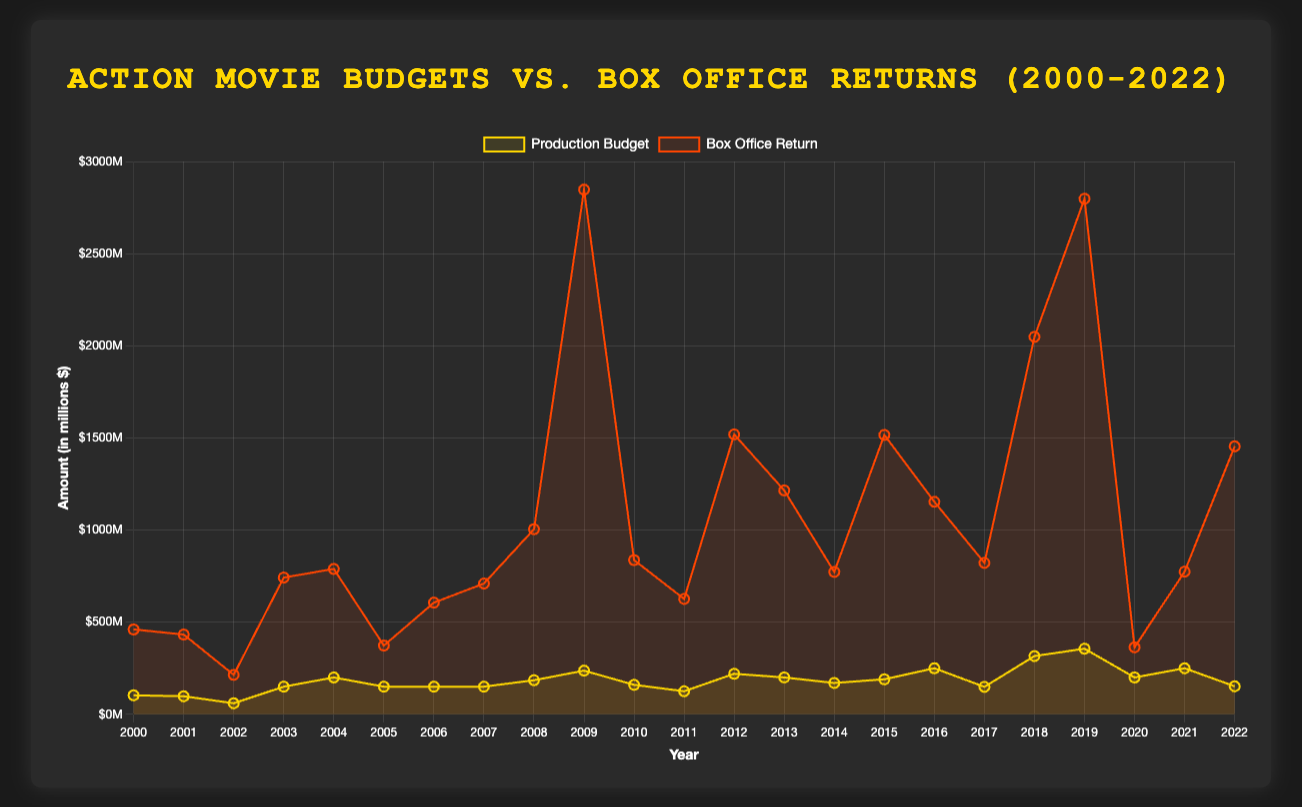Which movie had the highest box office return? To determine the movie with the highest box office return, look for the peak on the "Box Office Return" line. The figure shows that the highest point is in 2009 for "Avatar".
Answer: Avatar Which year saw the largest increase in production budget compared to the previous year? To find the largest increase in production budget, compare the vertical distances between consecutive points on the "Production Budget" line. The significant increase is from 2007 (150M for Transformers) to 2008 (185M for The Dark Knight), an increase of 35M.
Answer: 2008 In which year did the box office return surpass $1 billion for the first time? To identify when the box office return first surpassed $1 billion, look for the first point above the $1 billion mark on the "Box Office Return" line. This occurs in 2008 with "The Dark Knight".
Answer: 2008 What is the average box office return for the movies released in even years between 2000 and 2022? Calculate the average box office return for all movies released in even years (2000, 2002, 2004, ..., 2022). The returns are: 460.58M (2000), 214.03M (2002), 789M (2004), 606.1M (2006), 1004.56M (2008), 836.85M (2010), 1214.81M (2012), 772.78M (2014), 1516.05M (2016), 2048.36M (2018), 363.66M (2020), 1454.35M (2022). The sum is 11271.67M, and there are 12 movies, hence the average is 939.31M.
Answer: 939.31M Which movie had a production budget of $250 million and what was its box office return? Look for the data point on the "Production Budget" line where the value is $250 million. This budget corresponds to two movies: "Captain America: Civil War" in 2016 and "No Time to Die" in 2021. Their box office returns are 1153.30M and 774.15M respectively.
Answer: Captain America: Civil War, 1153.30M and No Time to Die, 774.15M Which year saw the largest disparity between production budget and box office return? To determine the year with the largest disparity between production budget and box office return, calculate the difference between the two values for each year. The largest disparity appears to be in 2009 for "Avatar" with a budget of 237M and a return of 2847.25M, resulting in a difference of 2610.25M.
Answer: 2009 How did the box office return for "Gladiator" compare to the "Iron Man 3"? Compare the box office returns for "Gladiator" in 2000 and "Iron Man 3" in 2013. "Gladiator" had a return of 460.58M while "Iron Man 3" had a return of 1214.81M. "Iron Man 3" significantly outperformed "Gladiator".
Answer: Iron Man 3 outperformed Gladiator Which movie in the 2010s had the highest production budget and what was it? Locate the highest point on the "Production Budget" line within the 2010-2019 range. This peak occurs in 2019 with "Avengers: Endgame", which had a budget of $356 million.
Answer: Avengers: Endgame, 356M What is the total box office return for the "Avengers" series listed in the data? The "Avengers" series includes "The Avengers" (2012), "Avengers: Infinity War" (2018), and "Avengers: Endgame" (2019). Their returns are 1518.81M, 2048.36M, and 2797.80M respectively. Sum them up to get the total: 6364.97M.
Answer: 6364.97M 